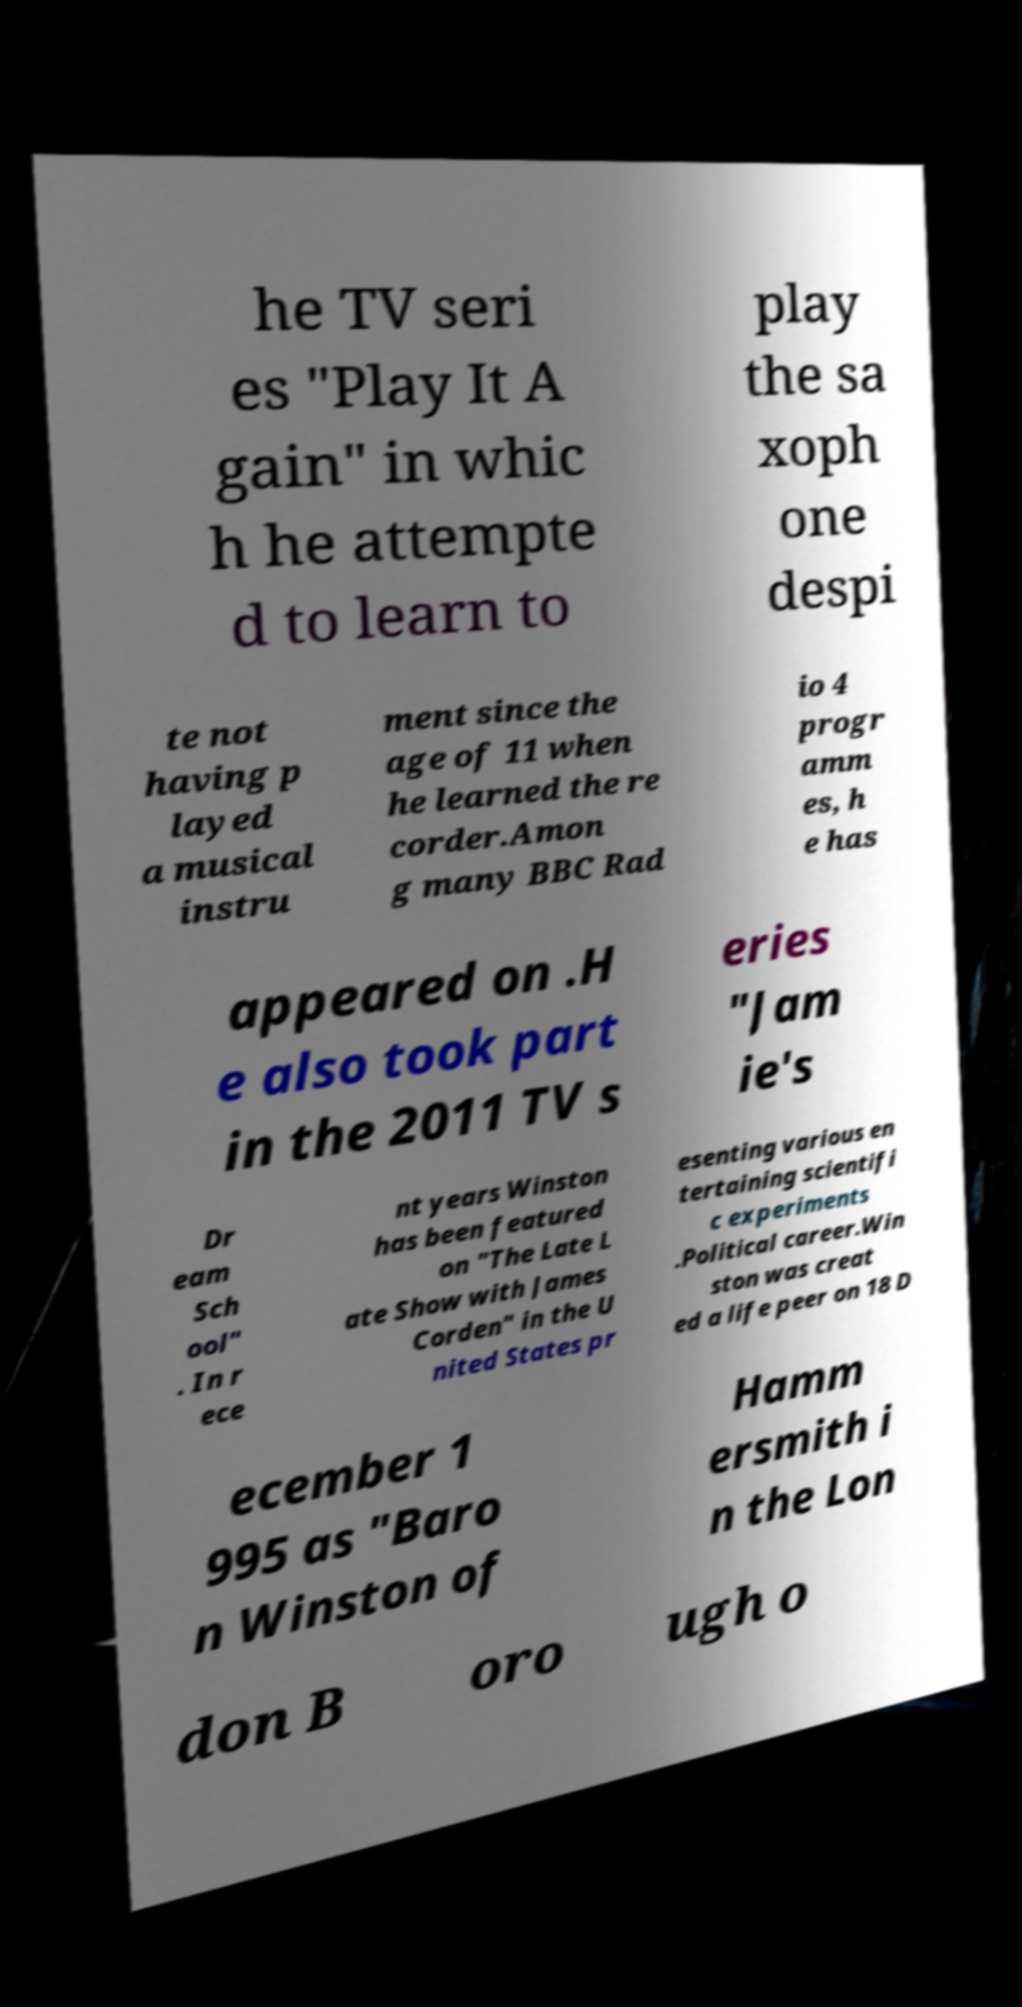Can you read and provide the text displayed in the image?This photo seems to have some interesting text. Can you extract and type it out for me? he TV seri es "Play It A gain" in whic h he attempte d to learn to play the sa xoph one despi te not having p layed a musical instru ment since the age of 11 when he learned the re corder.Amon g many BBC Rad io 4 progr amm es, h e has appeared on .H e also took part in the 2011 TV s eries "Jam ie's Dr eam Sch ool" . In r ece nt years Winston has been featured on "The Late L ate Show with James Corden" in the U nited States pr esenting various en tertaining scientifi c experiments .Political career.Win ston was creat ed a life peer on 18 D ecember 1 995 as "Baro n Winston of Hamm ersmith i n the Lon don B oro ugh o 